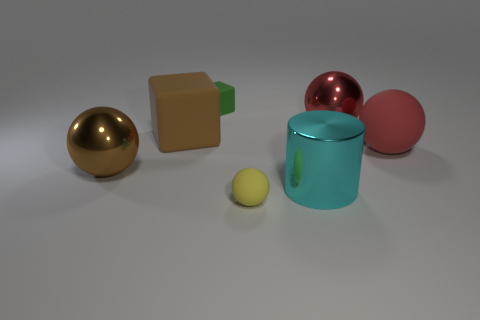This scene gives a very minimalistic vibe. What can you tell me about the lighting and mood? The lighting in the image is soft and diffused, providing gentle shadows and a calming feel. The neutral background and balanced composition contribute to a minimalistic and clean aesthetic, often associated with modern and tranquil settings. Are there any reflections or textures in the image that are noteworthy? Yes, the reflective surfaces of the metallic balls create interesting highlights and mirror the environment, adding depth to the scene. The contrasting textures between the matte and shiny objects also enhance the visual interest, emphasizing the play of light on different materials. 